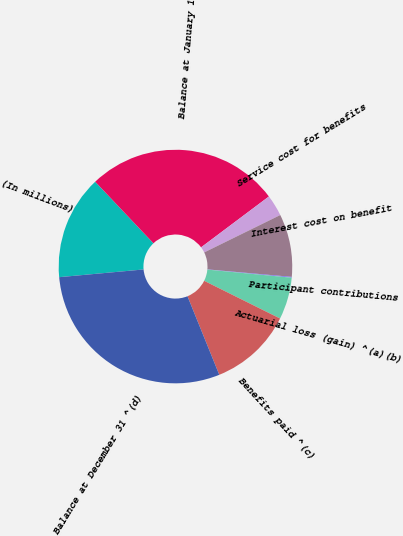Convert chart. <chart><loc_0><loc_0><loc_500><loc_500><pie_chart><fcel>(In millions)<fcel>Balance at January 1<fcel>Service cost for benefits<fcel>Interest cost on benefit<fcel>Participant contributions<fcel>Actuarial loss (gain) ^(a)(b)<fcel>Benefits paid ^(c)<fcel>Balance at December 31 ^(d)<nl><fcel>14.39%<fcel>26.82%<fcel>2.97%<fcel>8.68%<fcel>0.11%<fcel>5.82%<fcel>11.54%<fcel>29.67%<nl></chart> 